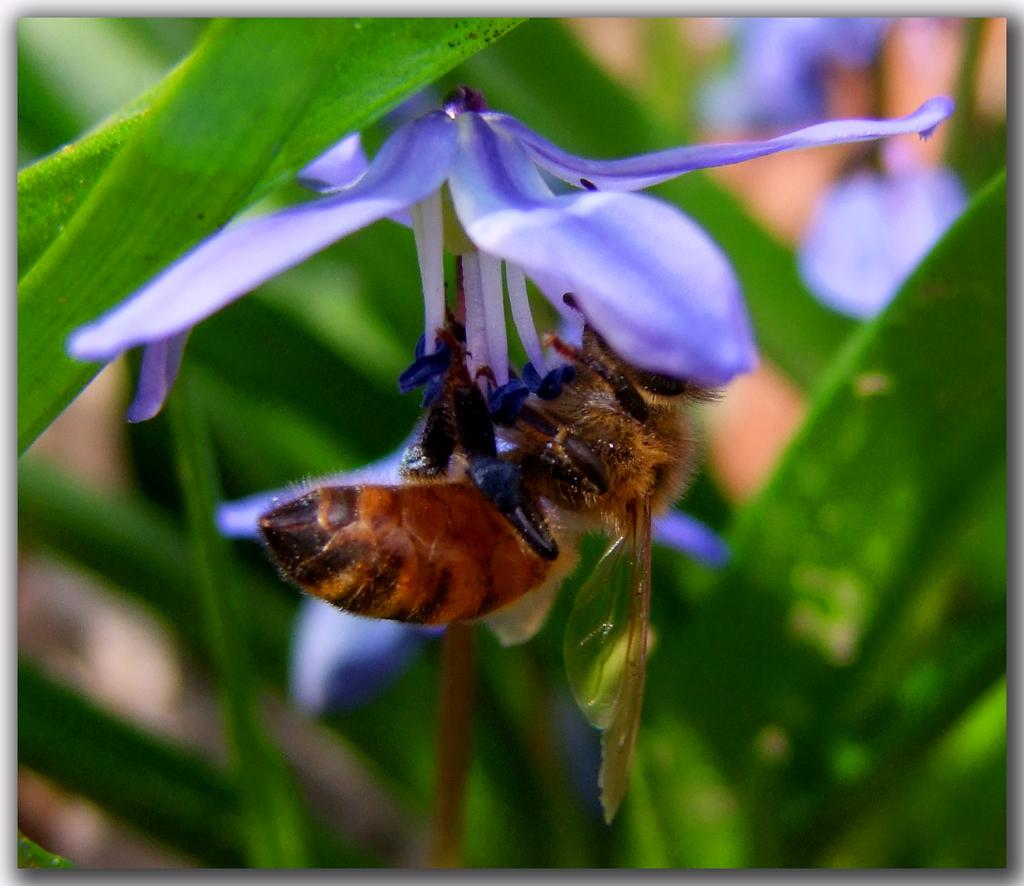What type of flower is in the image? There is a purple flower in the image. What else can be seen in the image besides the flower? There are leaves in the image. Is there any wildlife present in the image? Yes, there is a honey bee on the flower. What is the color of the honey bee? The honey bee is brown in color. How would you describe the background of the image? The background of the image is blurry. What is the honey bee thinking about on the page in the image? There is no page present in the image, and the honey bee's thoughts cannot be determined. 